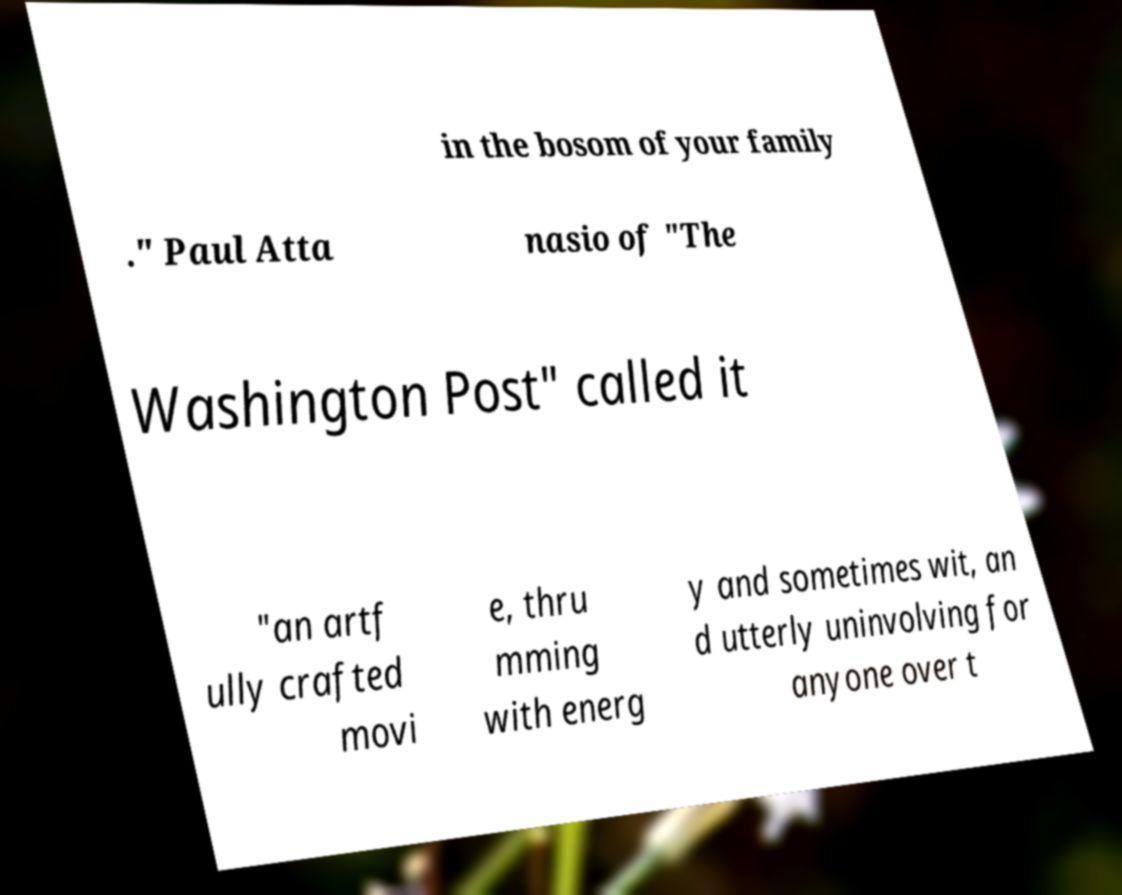Can you read and provide the text displayed in the image?This photo seems to have some interesting text. Can you extract and type it out for me? in the bosom of your family ." Paul Atta nasio of "The Washington Post" called it "an artf ully crafted movi e, thru mming with energ y and sometimes wit, an d utterly uninvolving for anyone over t 